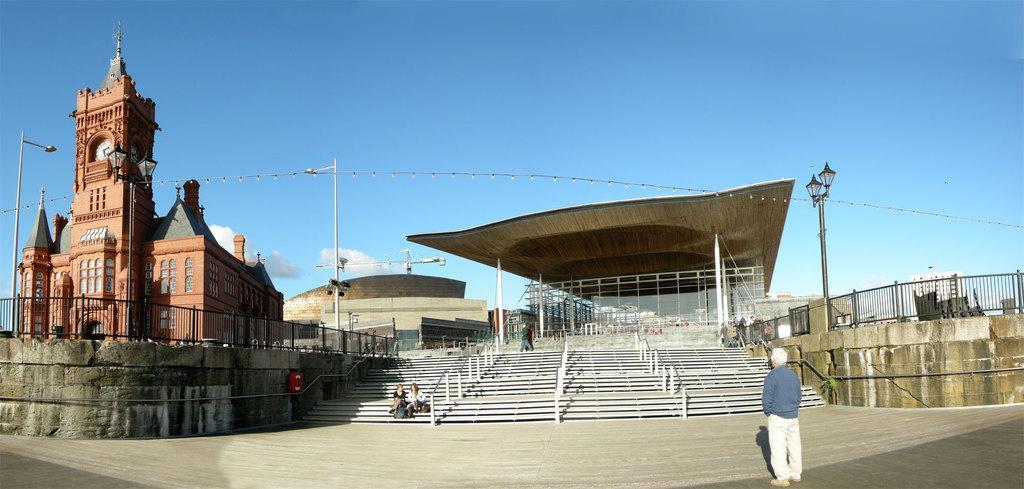Describe this image in one or two sentences. In this image there is a ground in the bottom of this image and there are some stairs in the middle of this image. There is a church on the left side of this image and there is a wall as we can see on the right side of this image. There are some current polls on the left side of this image. There is a fencing in the bottom left side of this image and bottom right side of this image as well. There is a blue sky on the top of this image. There is one person standing on the right side of this image and there are some persons are in the middle of this image. 